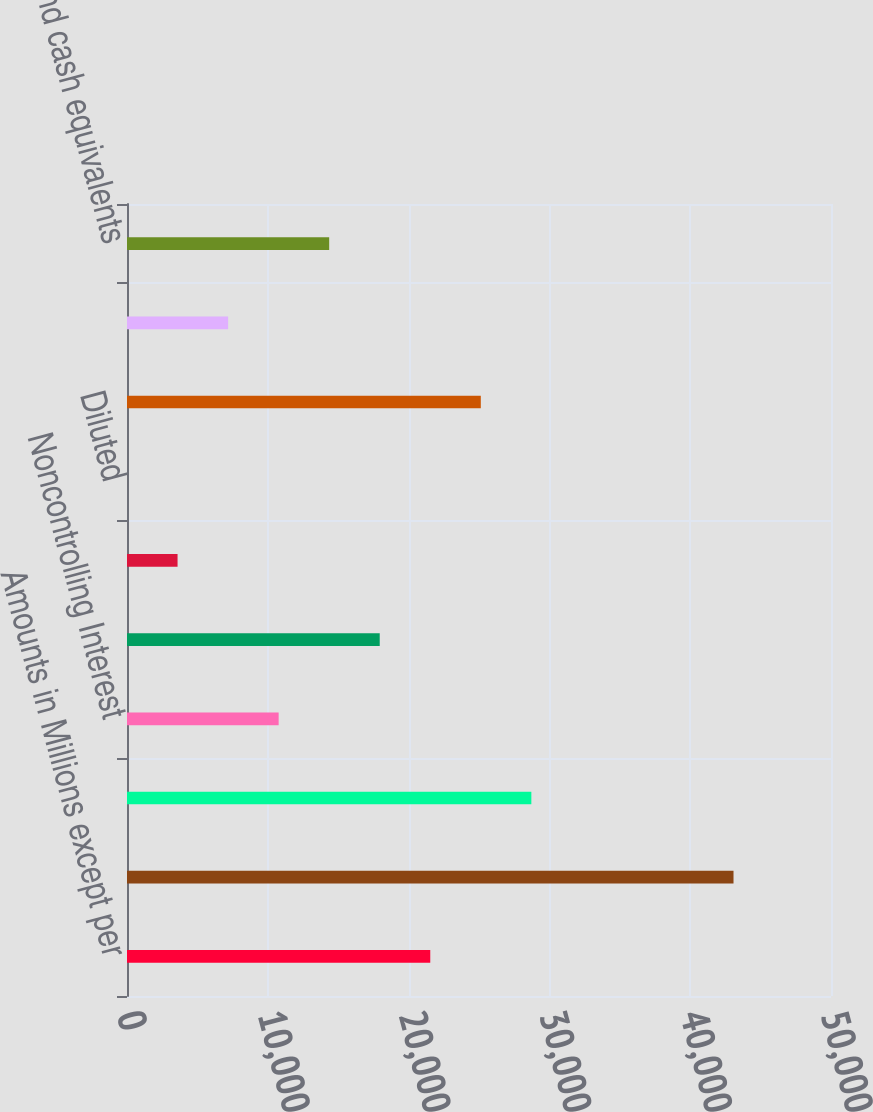Convert chart to OTSL. <chart><loc_0><loc_0><loc_500><loc_500><bar_chart><fcel>Amounts in Millions except per<fcel>Total Revenues<fcel>Net Earnings<fcel>Noncontrolling Interest<fcel>BMS<fcel>Basic<fcel>Diluted<fcel>Cash dividends paid on BMS<fcel>Cash dividends declared per<fcel>Cash and cash equivalents<nl><fcel>21538.6<fcel>43076.1<fcel>28717.8<fcel>10769.9<fcel>17949.1<fcel>3590.74<fcel>1.16<fcel>25128.2<fcel>7180.32<fcel>14359.5<nl></chart> 